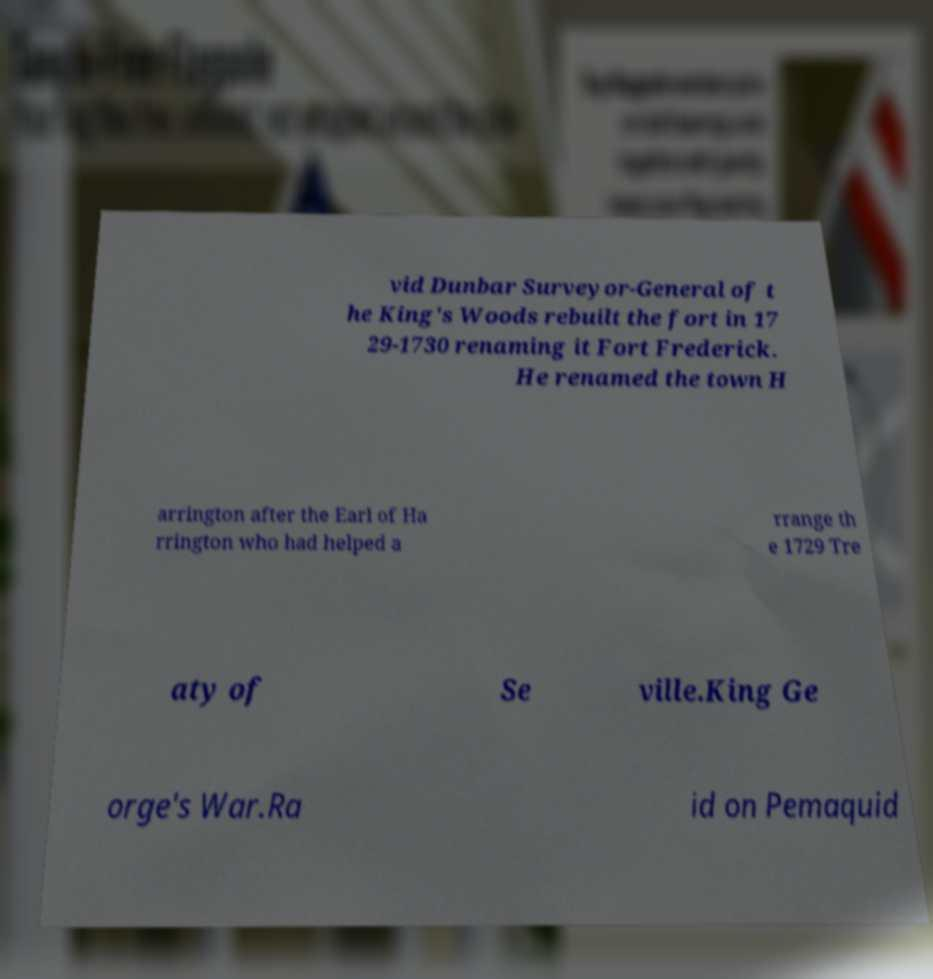Please identify and transcribe the text found in this image. vid Dunbar Surveyor-General of t he King's Woods rebuilt the fort in 17 29-1730 renaming it Fort Frederick. He renamed the town H arrington after the Earl of Ha rrington who had helped a rrange th e 1729 Tre aty of Se ville.King Ge orge's War.Ra id on Pemaquid 